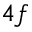<formula> <loc_0><loc_0><loc_500><loc_500>4 f</formula> 